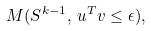Convert formula to latex. <formula><loc_0><loc_0><loc_500><loc_500>M ( { S } ^ { k - 1 } , \, { u } ^ { T } { v } \leq \epsilon ) ,</formula> 